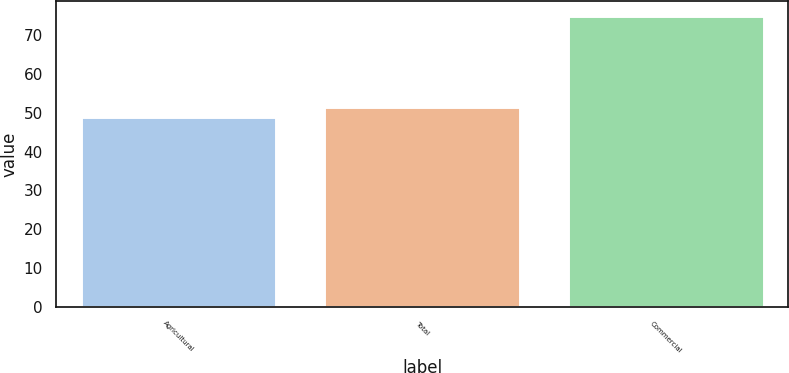Convert chart. <chart><loc_0><loc_0><loc_500><loc_500><bar_chart><fcel>Agricultural<fcel>Total<fcel>Commercial<nl><fcel>49<fcel>51.6<fcel>75<nl></chart> 